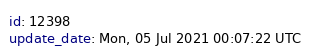<code> <loc_0><loc_0><loc_500><loc_500><_YAML_>id: 12398
update_date: Mon, 05 Jul 2021 00:07:22 UTC
</code> 